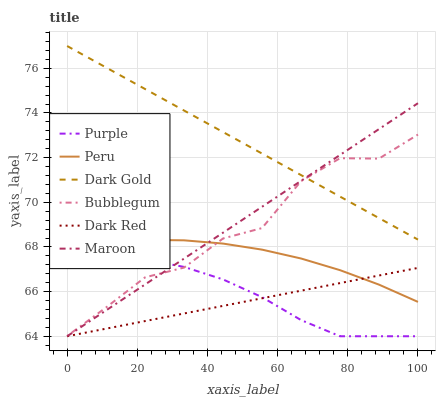Does Dark Red have the minimum area under the curve?
Answer yes or no. Yes. Does Dark Gold have the maximum area under the curve?
Answer yes or no. Yes. Does Purple have the minimum area under the curve?
Answer yes or no. No. Does Purple have the maximum area under the curve?
Answer yes or no. No. Is Dark Gold the smoothest?
Answer yes or no. Yes. Is Bubblegum the roughest?
Answer yes or no. Yes. Is Purple the smoothest?
Answer yes or no. No. Is Purple the roughest?
Answer yes or no. No. Does Bubblegum have the lowest value?
Answer yes or no. No. Does Dark Gold have the highest value?
Answer yes or no. Yes. Does Purple have the highest value?
Answer yes or no. No. Is Dark Red less than Dark Gold?
Answer yes or no. Yes. Is Dark Gold greater than Purple?
Answer yes or no. Yes. Does Dark Red intersect Dark Gold?
Answer yes or no. No. 